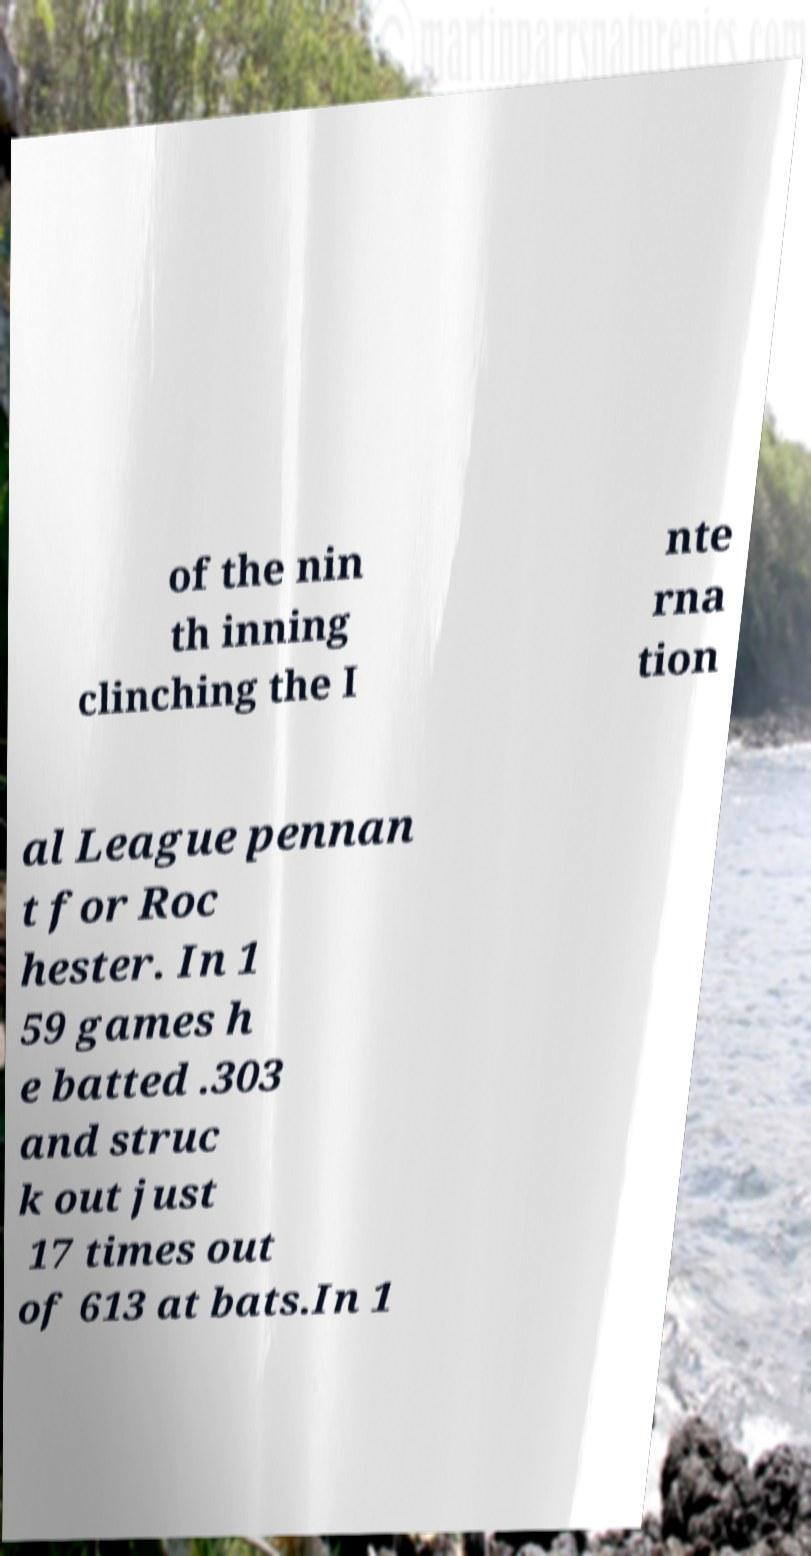Please read and relay the text visible in this image. What does it say? of the nin th inning clinching the I nte rna tion al League pennan t for Roc hester. In 1 59 games h e batted .303 and struc k out just 17 times out of 613 at bats.In 1 